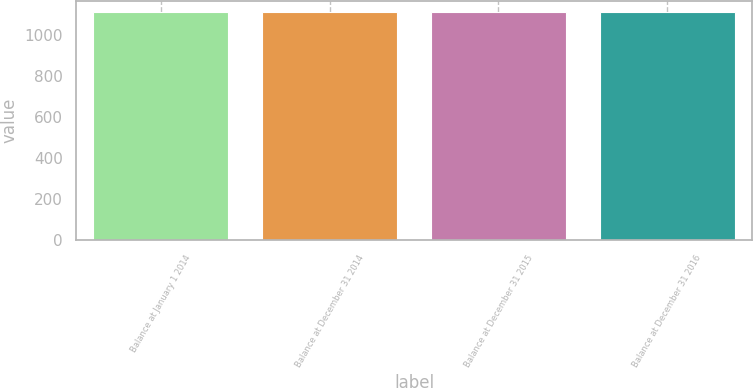Convert chart to OTSL. <chart><loc_0><loc_0><loc_500><loc_500><bar_chart><fcel>Balance at January 1 2014<fcel>Balance at December 31 2014<fcel>Balance at December 31 2015<fcel>Balance at December 31 2016<nl><fcel>1109.7<fcel>1110.1<fcel>1110.4<fcel>1111<nl></chart> 